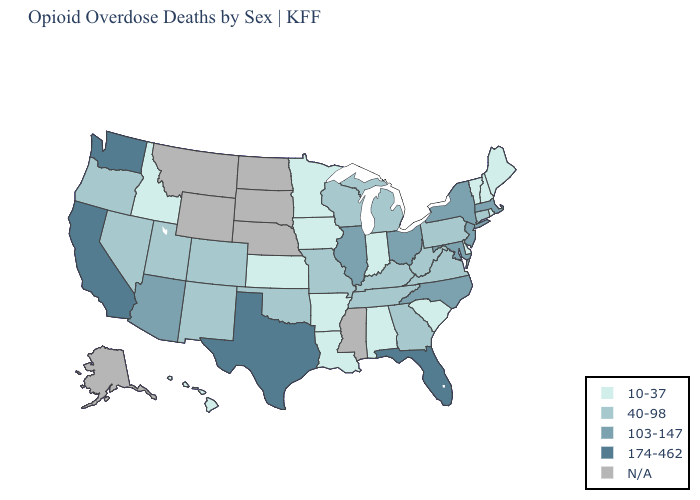What is the highest value in the South ?
Short answer required. 174-462. Does the first symbol in the legend represent the smallest category?
Keep it brief. Yes. Is the legend a continuous bar?
Keep it brief. No. Name the states that have a value in the range 174-462?
Give a very brief answer. California, Florida, Texas, Washington. What is the highest value in states that border Alabama?
Be succinct. 174-462. Name the states that have a value in the range 10-37?
Short answer required. Alabama, Arkansas, Delaware, Hawaii, Idaho, Indiana, Iowa, Kansas, Louisiana, Maine, Minnesota, New Hampshire, Rhode Island, South Carolina, Vermont. Does the first symbol in the legend represent the smallest category?
Quick response, please. Yes. What is the value of Minnesota?
Be succinct. 10-37. Among the states that border New Jersey , which have the highest value?
Answer briefly. New York. Does California have the highest value in the USA?
Keep it brief. Yes. Which states have the lowest value in the USA?
Give a very brief answer. Alabama, Arkansas, Delaware, Hawaii, Idaho, Indiana, Iowa, Kansas, Louisiana, Maine, Minnesota, New Hampshire, Rhode Island, South Carolina, Vermont. What is the value of Kentucky?
Short answer required. 40-98. Which states have the lowest value in the MidWest?
Answer briefly. Indiana, Iowa, Kansas, Minnesota. What is the highest value in the MidWest ?
Give a very brief answer. 103-147. 